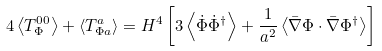<formula> <loc_0><loc_0><loc_500><loc_500>4 \left \langle T _ { \Phi } ^ { 0 0 } \right \rangle + \left \langle T _ { \Phi a } ^ { a } \right \rangle = H ^ { 4 } \left [ 3 \left \langle \dot { \Phi } \dot { \Phi } ^ { \dagger } \right \rangle + \frac { 1 } { a ^ { 2 } } \left \langle \bar { \nabla } \Phi \cdot \bar { \nabla } \Phi ^ { \dagger } \right \rangle \right ]</formula> 